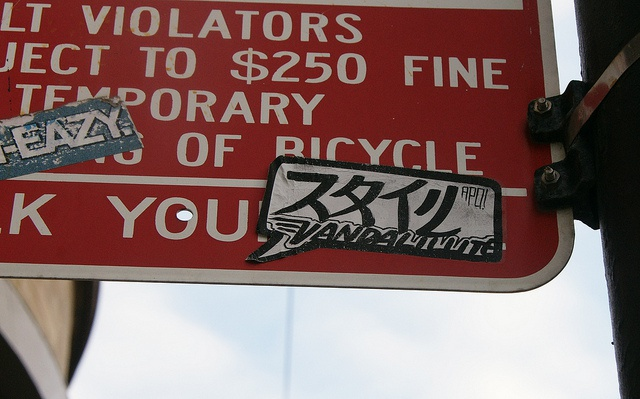Describe the objects in this image and their specific colors. I can see various objects in this image with different colors. 